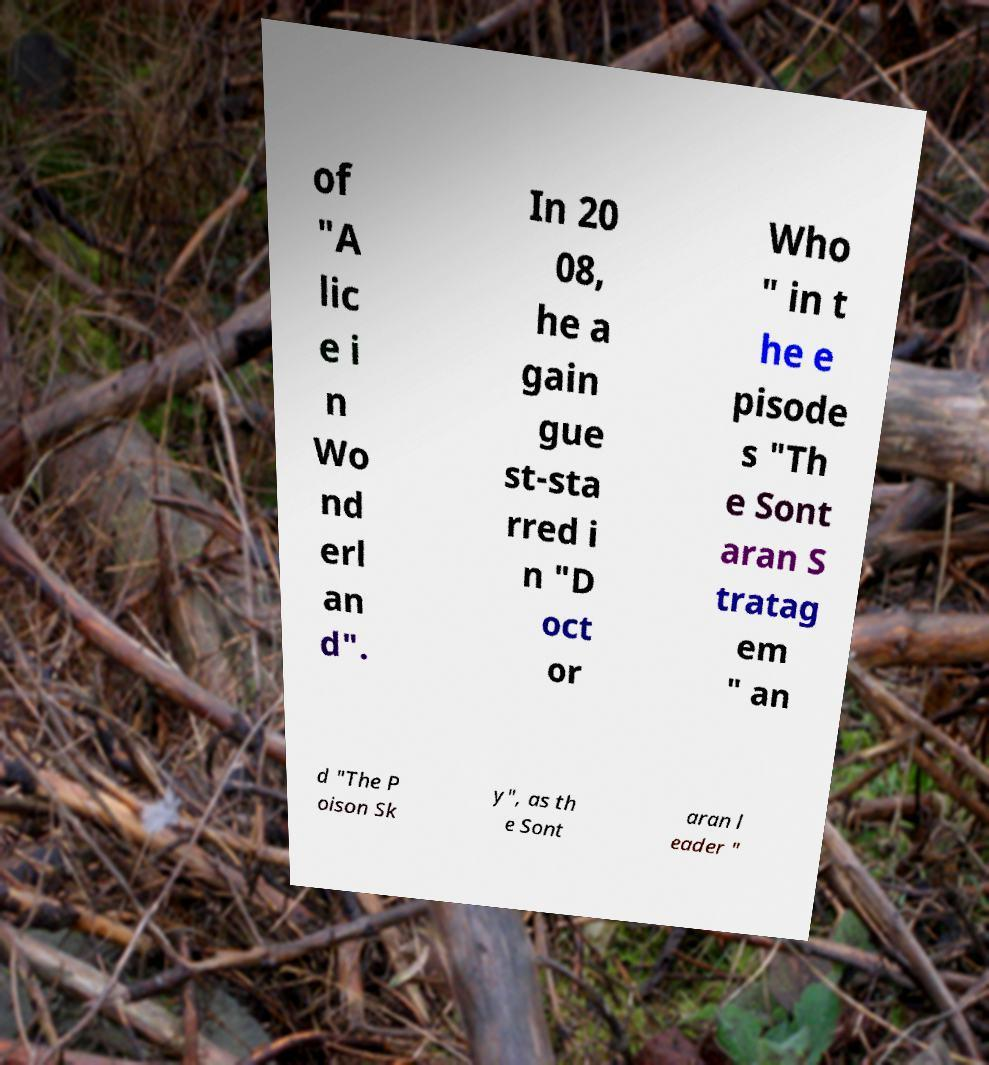Could you assist in decoding the text presented in this image and type it out clearly? of "A lic e i n Wo nd erl an d". In 20 08, he a gain gue st-sta rred i n "D oct or Who " in t he e pisode s "Th e Sont aran S tratag em " an d "The P oison Sk y", as th e Sont aran l eader " 